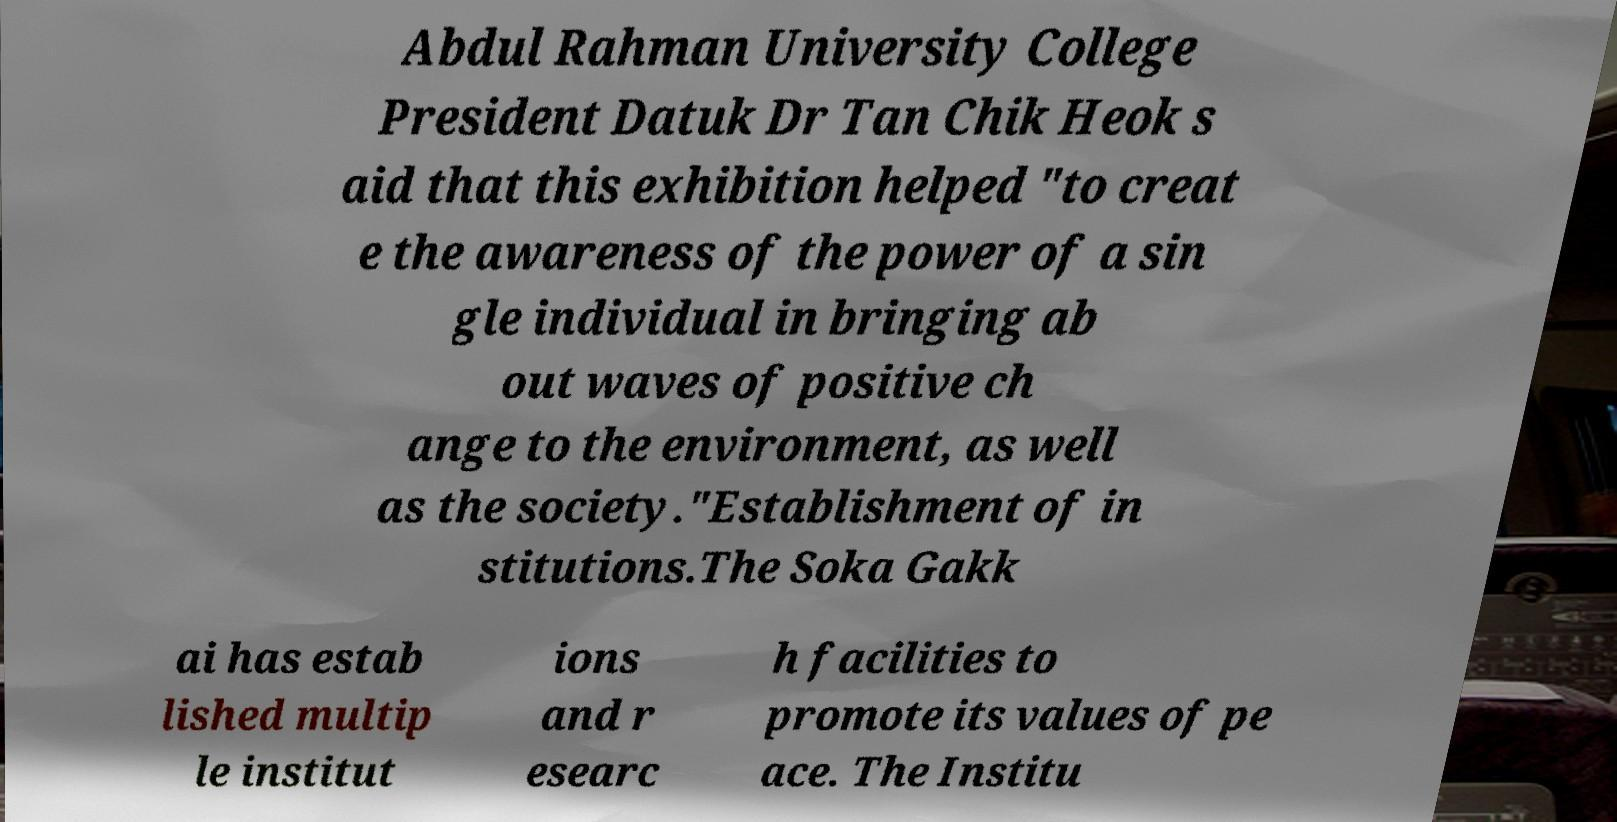There's text embedded in this image that I need extracted. Can you transcribe it verbatim? Abdul Rahman University College President Datuk Dr Tan Chik Heok s aid that this exhibition helped "to creat e the awareness of the power of a sin gle individual in bringing ab out waves of positive ch ange to the environment, as well as the society."Establishment of in stitutions.The Soka Gakk ai has estab lished multip le institut ions and r esearc h facilities to promote its values of pe ace. The Institu 